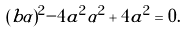Convert formula to latex. <formula><loc_0><loc_0><loc_500><loc_500>( b \alpha ) ^ { 2 } - 4 a ^ { 2 } \alpha ^ { 2 } + 4 a ^ { 2 } = 0 .</formula> 